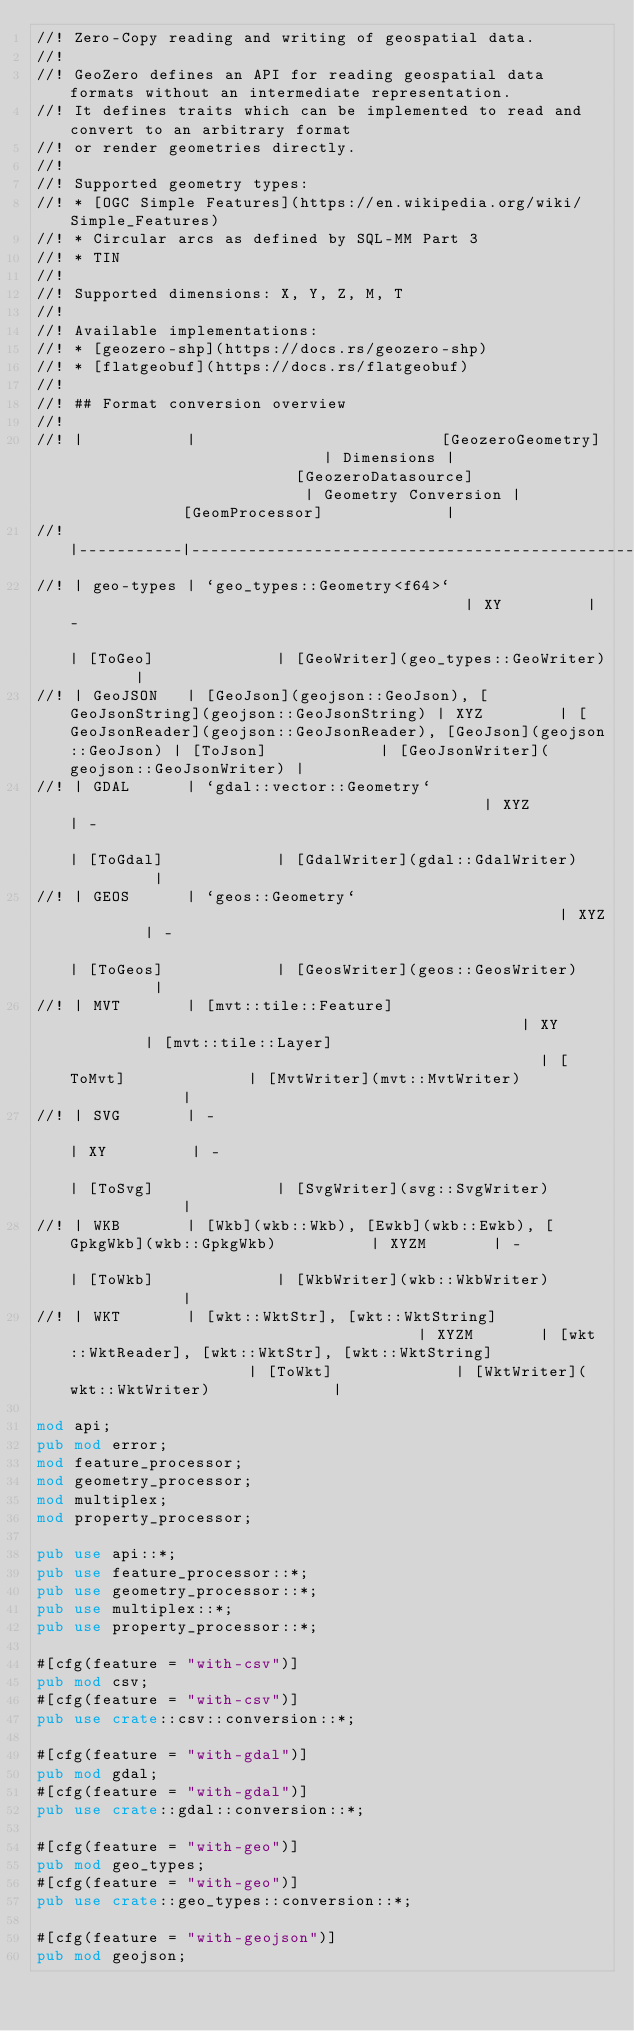Convert code to text. <code><loc_0><loc_0><loc_500><loc_500><_Rust_>//! Zero-Copy reading and writing of geospatial data.
//!
//! GeoZero defines an API for reading geospatial data formats without an intermediate representation.
//! It defines traits which can be implemented to read and convert to an arbitrary format
//! or render geometries directly.
//!
//! Supported geometry types:
//! * [OGC Simple Features](https://en.wikipedia.org/wiki/Simple_Features)
//! * Circular arcs as defined by SQL-MM Part 3
//! * TIN
//!
//! Supported dimensions: X, Y, Z, M, T
//!
//! Available implementations:
//! * [geozero-shp](https://docs.rs/geozero-shp)
//! * [flatgeobuf](https://docs.rs/flatgeobuf)
//!
//! ## Format conversion overview
//!
//! |           |                          [GeozeroGeometry]                           | Dimensions |                         [GeozeroDatasource]                          | Geometry Conversion |             [GeomProcessor]             |
//! |-----------|----------------------------------------------------------------------|------------|----------------------------------------------------------------------|---------------------|-----------------------------------------|
//! | geo-types | `geo_types::Geometry<f64>`                                           | XY         | -                                                                    | [ToGeo]             | [GeoWriter](geo_types::GeoWriter)       |
//! | GeoJSON   | [GeoJson](geojson::GeoJson), [GeoJsonString](geojson::GeoJsonString) | XYZ        | [GeoJsonReader](geojson::GeoJsonReader), [GeoJson](geojson::GeoJson) | [ToJson]            | [GeoJsonWriter](geojson::GeoJsonWriter) |
//! | GDAL      | `gdal::vector::Geometry`                                             | XYZ        | -                                                                    | [ToGdal]            | [GdalWriter](gdal::GdalWriter)          |
//! | GEOS      | `geos::Geometry`                                                     | XYZ        | -                                                                    | [ToGeos]            | [GeosWriter](geos::GeosWriter)          |
//! | MVT       | [mvt::tile::Feature]                                                 | XY         | [mvt::tile::Layer]                                                   | [ToMvt]             | [MvtWriter](mvt::MvtWriter)             |
//! | SVG       | -                                                                    | XY         | -                                                                    | [ToSvg]             | [SvgWriter](svg::SvgWriter)             |
//! | WKB       | [Wkb](wkb::Wkb), [Ewkb](wkb::Ewkb), [GpkgWkb](wkb::GpkgWkb)          | XYZM       | -                                                                    | [ToWkb]             | [WkbWriter](wkb::WkbWriter)             |
//! | WKT       | [wkt::WktStr], [wkt::WktString]                                      | XYZM       | [wkt::WktReader], [wkt::WktStr], [wkt::WktString]                    | [ToWkt]             | [WktWriter](wkt::WktWriter)             |

mod api;
pub mod error;
mod feature_processor;
mod geometry_processor;
mod multiplex;
mod property_processor;

pub use api::*;
pub use feature_processor::*;
pub use geometry_processor::*;
pub use multiplex::*;
pub use property_processor::*;

#[cfg(feature = "with-csv")]
pub mod csv;
#[cfg(feature = "with-csv")]
pub use crate::csv::conversion::*;

#[cfg(feature = "with-gdal")]
pub mod gdal;
#[cfg(feature = "with-gdal")]
pub use crate::gdal::conversion::*;

#[cfg(feature = "with-geo")]
pub mod geo_types;
#[cfg(feature = "with-geo")]
pub use crate::geo_types::conversion::*;

#[cfg(feature = "with-geojson")]
pub mod geojson;</code> 